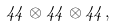Convert formula to latex. <formula><loc_0><loc_0><loc_500><loc_500>4 4 \otimes 4 4 \otimes 4 4 ,</formula> 